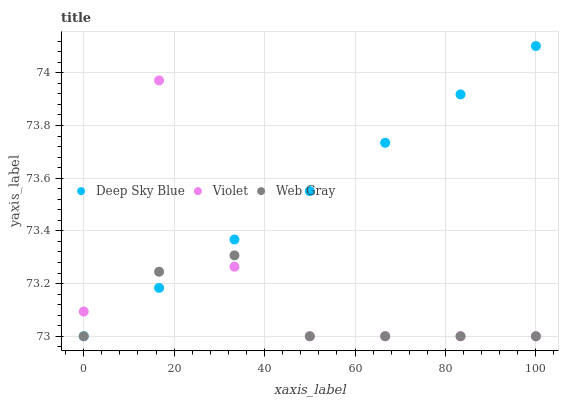Does Web Gray have the minimum area under the curve?
Answer yes or no. Yes. Does Deep Sky Blue have the maximum area under the curve?
Answer yes or no. Yes. Does Violet have the minimum area under the curve?
Answer yes or no. No. Does Violet have the maximum area under the curve?
Answer yes or no. No. Is Deep Sky Blue the smoothest?
Answer yes or no. Yes. Is Violet the roughest?
Answer yes or no. Yes. Is Violet the smoothest?
Answer yes or no. No. Is Deep Sky Blue the roughest?
Answer yes or no. No. Does Web Gray have the lowest value?
Answer yes or no. Yes. Does Deep Sky Blue have the highest value?
Answer yes or no. Yes. Does Violet have the highest value?
Answer yes or no. No. Does Web Gray intersect Deep Sky Blue?
Answer yes or no. Yes. Is Web Gray less than Deep Sky Blue?
Answer yes or no. No. Is Web Gray greater than Deep Sky Blue?
Answer yes or no. No. 